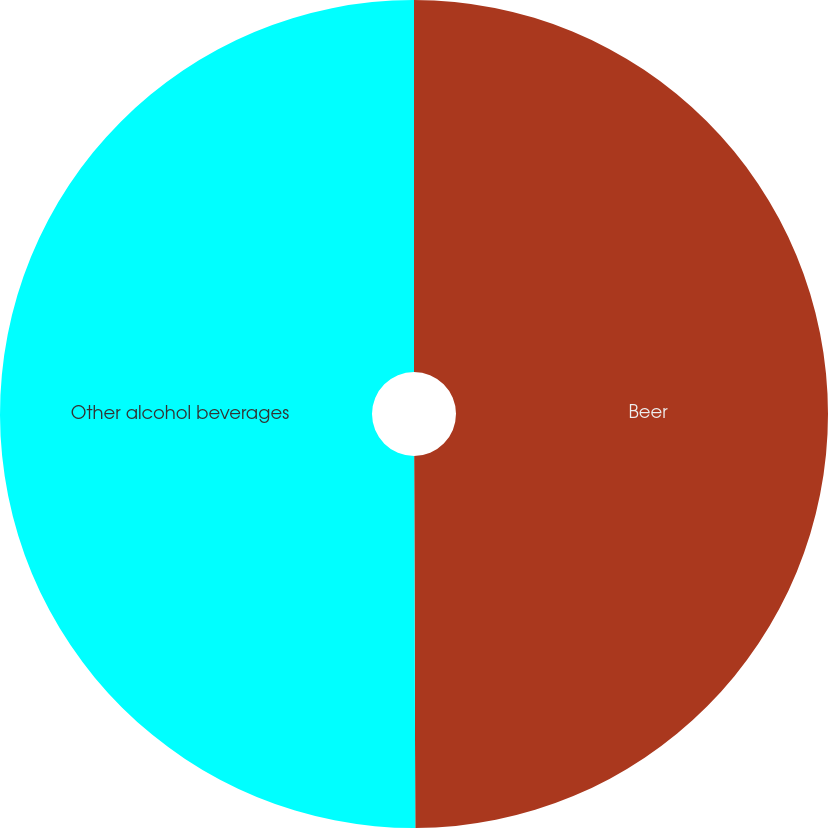Convert chart. <chart><loc_0><loc_0><loc_500><loc_500><pie_chart><fcel>Beer<fcel>Other alcohol beverages<nl><fcel>49.95%<fcel>50.05%<nl></chart> 